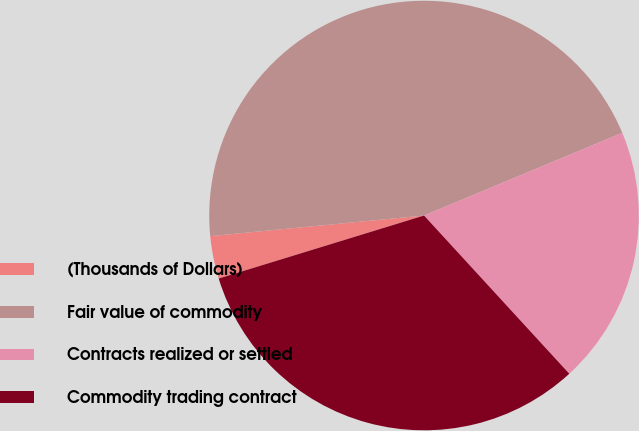Convert chart. <chart><loc_0><loc_0><loc_500><loc_500><pie_chart><fcel>(Thousands of Dollars)<fcel>Fair value of commodity<fcel>Contracts realized or settled<fcel>Commodity trading contract<nl><fcel>3.21%<fcel>45.24%<fcel>19.47%<fcel>32.08%<nl></chart> 